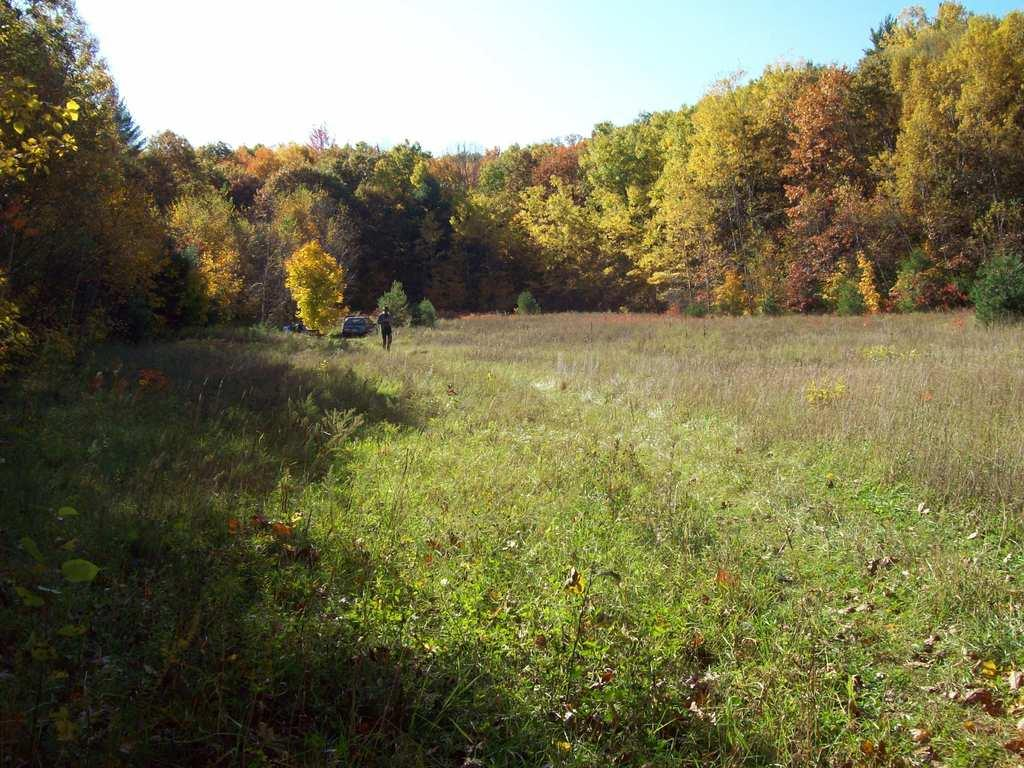What type of vegetation is present at the bottom of the image? There are plants and grass at the bottom of the image. Can you describe the background of the image? There is a person, a vehicle, and trees in the background of the image. What is visible at the top of the image? The sky is visible at the top of the image. What type of fruit is hanging from the trees in the image? There is no fruit visible in the image; only trees are present in the background. Can you describe the yoke that the person is using in the image? There is no yoke present in the image; the person is not depicted using any such object. 